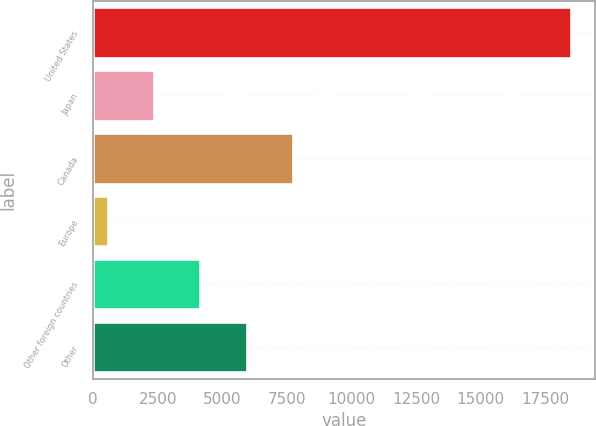Convert chart. <chart><loc_0><loc_0><loc_500><loc_500><bar_chart><fcel>United States<fcel>Japan<fcel>Canada<fcel>Europe<fcel>Other foreign countries<fcel>Other<nl><fcel>18497<fcel>2357.3<fcel>7737.2<fcel>564<fcel>4150.6<fcel>5943.9<nl></chart> 